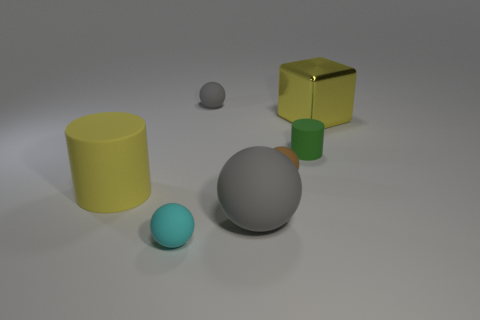Are there any other things that are the same material as the yellow block?
Make the answer very short. No. What number of other things are the same shape as the tiny cyan matte object?
Make the answer very short. 3. There is a large thing that is to the left of the big shiny object and to the right of the cyan matte ball; what shape is it?
Give a very brief answer. Sphere. There is a small cyan ball; are there any gray objects behind it?
Give a very brief answer. Yes. What is the size of the green thing that is the same shape as the large yellow rubber object?
Ensure brevity in your answer.  Small. Does the large gray thing have the same shape as the small gray object?
Offer a very short reply. Yes. What size is the ball that is behind the tiny thing on the right side of the small brown matte thing?
Your answer should be compact. Small. What color is the big thing that is the same shape as the tiny gray object?
Your answer should be compact. Gray. What number of small rubber cylinders are the same color as the metal cube?
Your response must be concise. 0. What size is the yellow metallic object?
Make the answer very short. Large. 